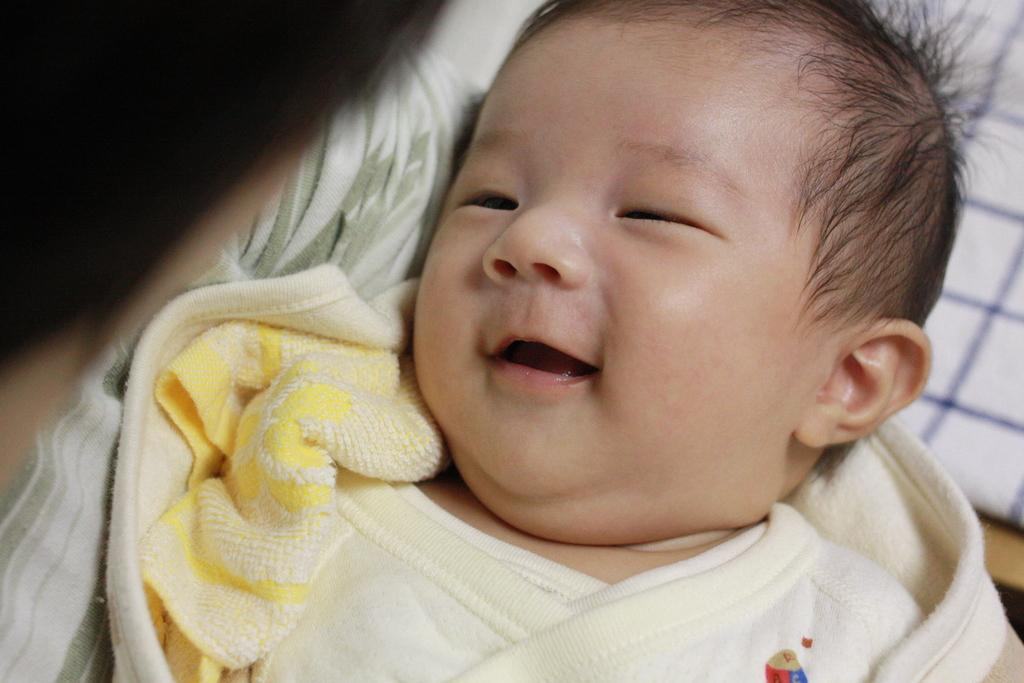What is the main subject of the image? There is a baby in the image. What is the baby doing in the image? The baby is smiling. What type of jewel is the baby wearing in the image? There is no mention of a jewel in the image, and the baby is not wearing any jewelry. Can you see any rabbits in the image? There are no rabbits present in the image; the main subject is a baby. 